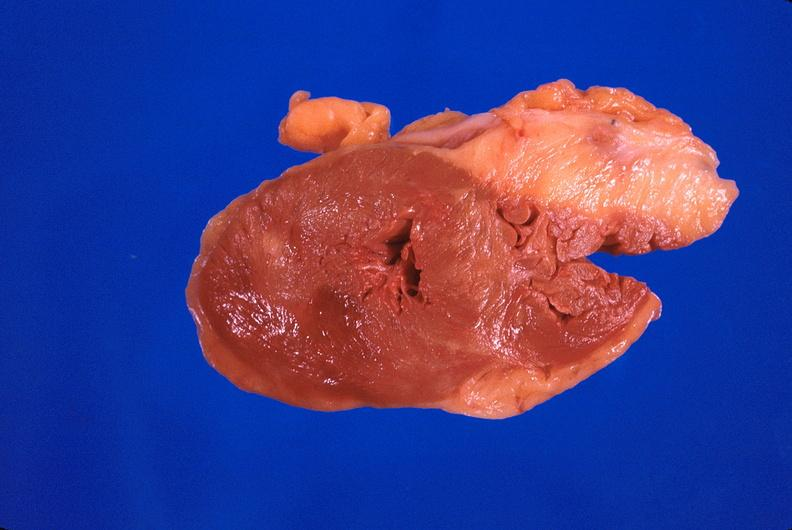where is this?
Answer the question using a single word or phrase. Heart 